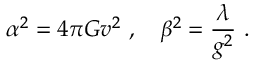<formula> <loc_0><loc_0><loc_500><loc_500>\alpha ^ { 2 } = 4 \pi G v ^ { 2 } \ , \quad b e t a ^ { 2 } = \frac { \lambda } { g ^ { 2 } } \ .</formula> 